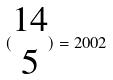Convert formula to latex. <formula><loc_0><loc_0><loc_500><loc_500>( \begin{matrix} 1 4 \\ 5 \end{matrix} ) = 2 0 0 2</formula> 